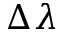<formula> <loc_0><loc_0><loc_500><loc_500>\Delta \lambda</formula> 